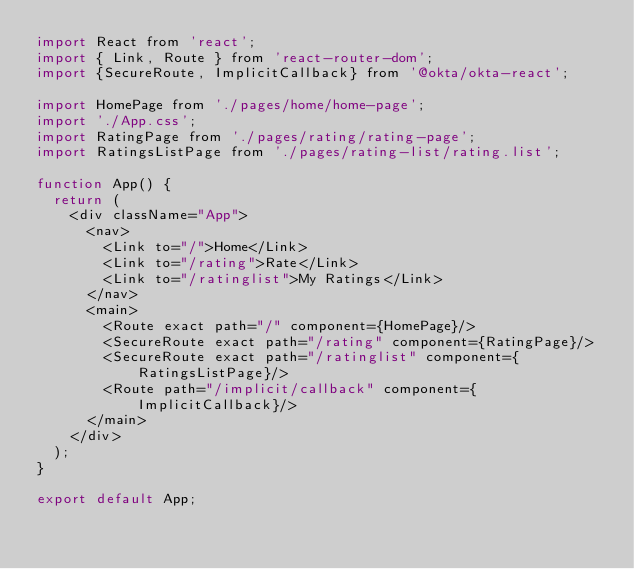Convert code to text. <code><loc_0><loc_0><loc_500><loc_500><_JavaScript_>import React from 'react';
import { Link, Route } from 'react-router-dom';
import {SecureRoute, ImplicitCallback} from '@okta/okta-react';

import HomePage from './pages/home/home-page';
import './App.css';
import RatingPage from './pages/rating/rating-page';
import RatingsListPage from './pages/rating-list/rating.list';

function App() {
  return (
    <div className="App">
      <nav>
        <Link to="/">Home</Link>
        <Link to="/rating">Rate</Link>
        <Link to="/ratinglist">My Ratings</Link>
      </nav>
      <main>
        <Route exact path="/" component={HomePage}/>
        <SecureRoute exact path="/rating" component={RatingPage}/>
        <SecureRoute exact path="/ratinglist" component={RatingsListPage}/>
        <Route path="/implicit/callback" component={ImplicitCallback}/>
      </main> 
    </div>
  );
}

export default App;
</code> 